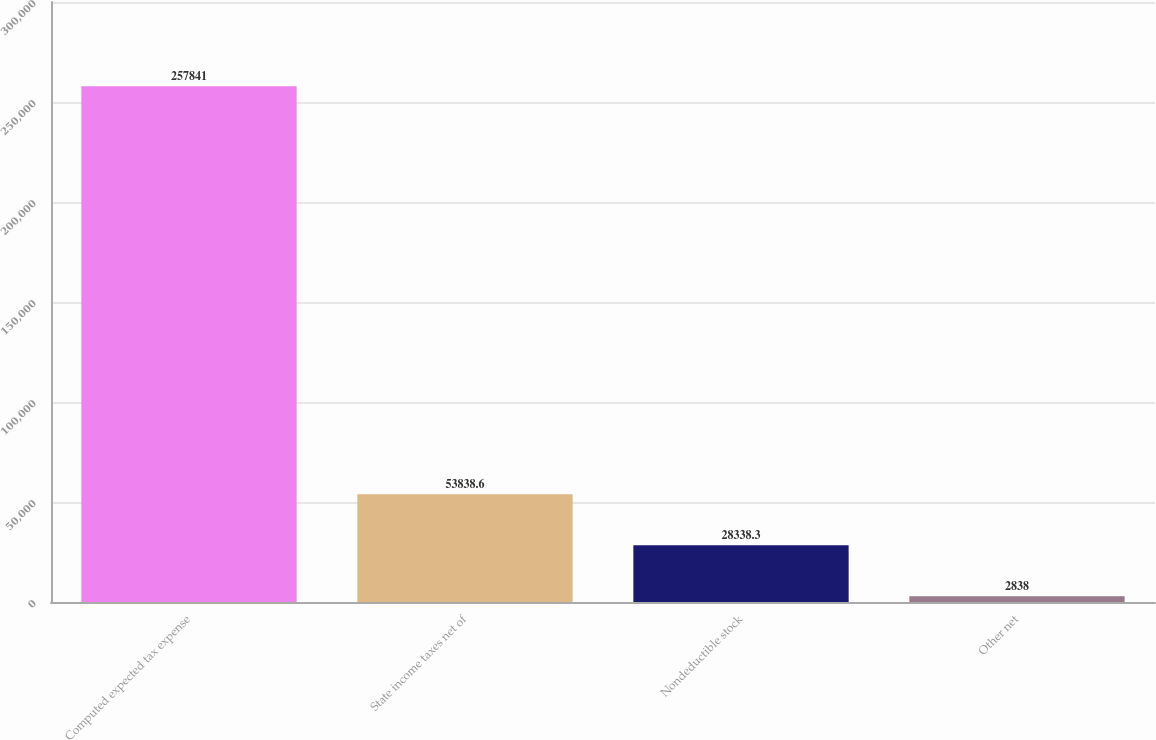Convert chart to OTSL. <chart><loc_0><loc_0><loc_500><loc_500><bar_chart><fcel>Computed expected tax expense<fcel>State income taxes net of<fcel>Nondeductible stock<fcel>Other net<nl><fcel>257841<fcel>53838.6<fcel>28338.3<fcel>2838<nl></chart> 